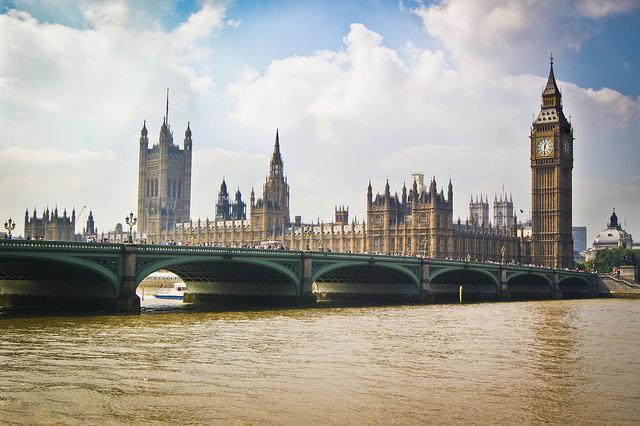How many clocks are shown?
Give a very brief answer. 1. 